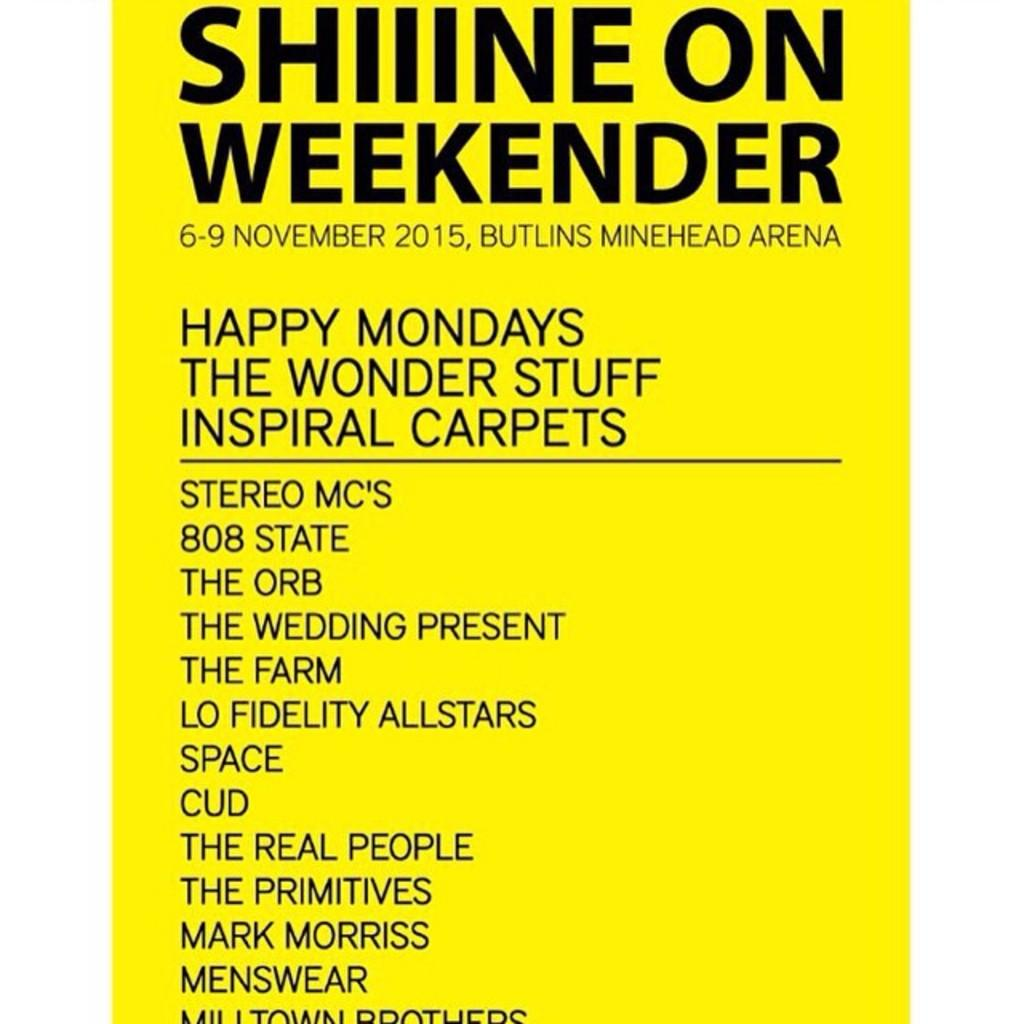<image>
Summarize the visual content of the image. Poster sign of Shiiine on weekender 6-9 November 2015, Butlins Minehead Arena. 